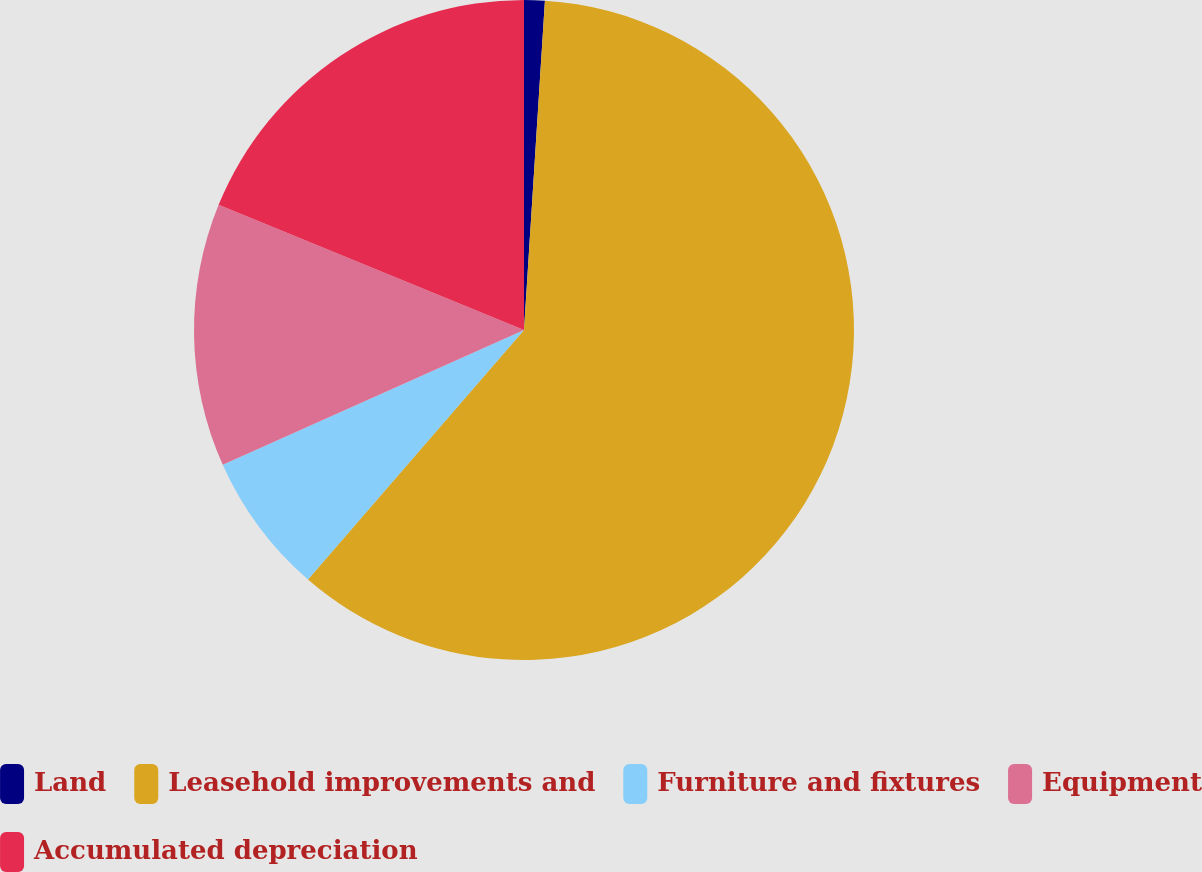<chart> <loc_0><loc_0><loc_500><loc_500><pie_chart><fcel>Land<fcel>Leasehold improvements and<fcel>Furniture and fixtures<fcel>Equipment<fcel>Accumulated depreciation<nl><fcel>1.01%<fcel>60.35%<fcel>6.95%<fcel>12.88%<fcel>18.81%<nl></chart> 